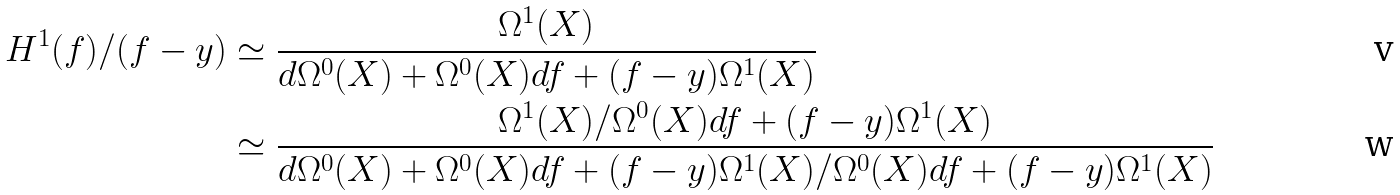<formula> <loc_0><loc_0><loc_500><loc_500>H ^ { 1 } ( f ) / ( f - y ) & \simeq \frac { \Omega ^ { 1 } ( X ) } { d \Omega ^ { 0 } ( X ) + \Omega ^ { 0 } ( X ) d f + ( f - y ) \Omega ^ { 1 } ( X ) } \\ & \simeq \frac { \Omega ^ { 1 } ( X ) / \Omega ^ { 0 } ( X ) d f + ( f - y ) \Omega ^ { 1 } ( X ) } { d \Omega ^ { 0 } ( X ) + \Omega ^ { 0 } ( X ) d f + ( f - y ) \Omega ^ { 1 } ( X ) / \Omega ^ { 0 } ( X ) d f + ( f - y ) \Omega ^ { 1 } ( X ) }</formula> 